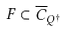Convert formula to latex. <formula><loc_0><loc_0><loc_500><loc_500>F \subset \overline { C } _ { Q ^ { \dagger } }</formula> 